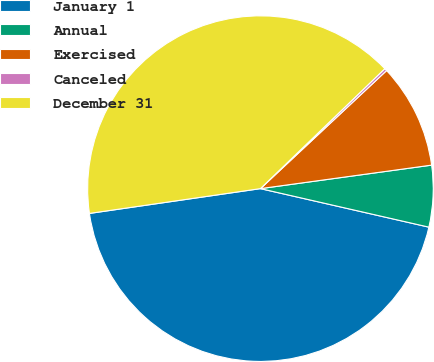<chart> <loc_0><loc_0><loc_500><loc_500><pie_chart><fcel>January 1<fcel>Annual<fcel>Exercised<fcel>Canceled<fcel>December 31<nl><fcel>44.13%<fcel>5.75%<fcel>9.8%<fcel>0.24%<fcel>40.08%<nl></chart> 